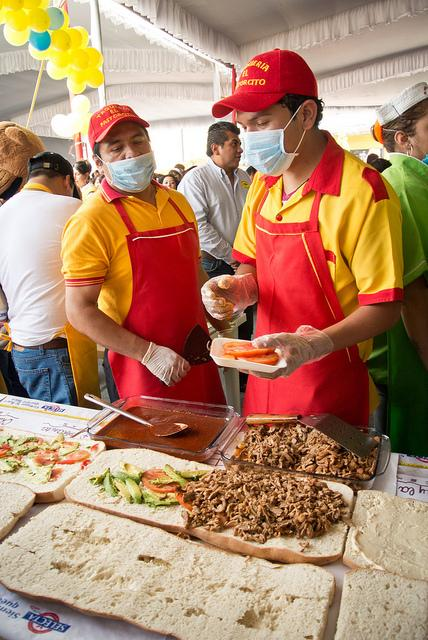These people are making what kind of food? sandwich 